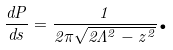<formula> <loc_0><loc_0><loc_500><loc_500>\frac { d P } { d s } = \frac { 1 } { 2 \pi \sqrt { 2 \Lambda ^ { 2 } - z ^ { 2 } } } \text {.}</formula> 